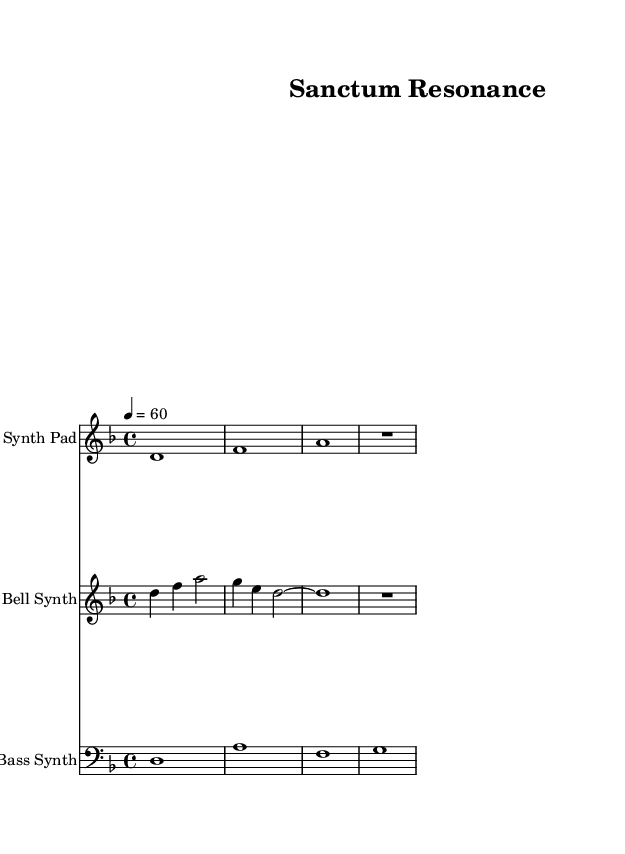What is the key signature of this music? The key signature shown in the music is D minor, which has one flat (B flat). This can be identified by looking at the key signature indication at the beginning of the staff.
Answer: D minor What is the time signature of the piece? The time signature is 4/4, which can be seen indicated at the beginning of the score. This means there are four beats in a measure and the quarter note gets one beat.
Answer: 4/4 What is the tempo marking for this piece? The tempo marking indicates that the piece should be played at a speed of 60 beats per minute. This can be found in the tempo indication, which specifies the subdivision of beats as a quarter note equals 60.
Answer: 60 What instrument is playing the Bell Synth part? The Bell Synth part is specified on its staff, which identifies it as "Bell Synth." This is clearly marked above the staff corresponding to this part.
Answer: Bell Synth How many measures are there in the Synth Pad part? The Synth Pad part contains 4 measures. This can be counted by looking at the vertical bar lines that separate each measure in the staff.
Answer: 4 What is the rhythmic value of the last note in the Bell Synth part? The last note in the Bell Synth part is a half note. This can be determined by looking at the note in question, which is represented with a hollow note head and a stem, indicating its duration.
Answer: Half note Which instruments are included in the score? The score includes three instruments: Synth Pad, Bell Synth, and Bass Synth. This is indicated at the beginning of each staff where the instrument name is labeled.
Answer: Synth Pad, Bell Synth, Bass Synth 